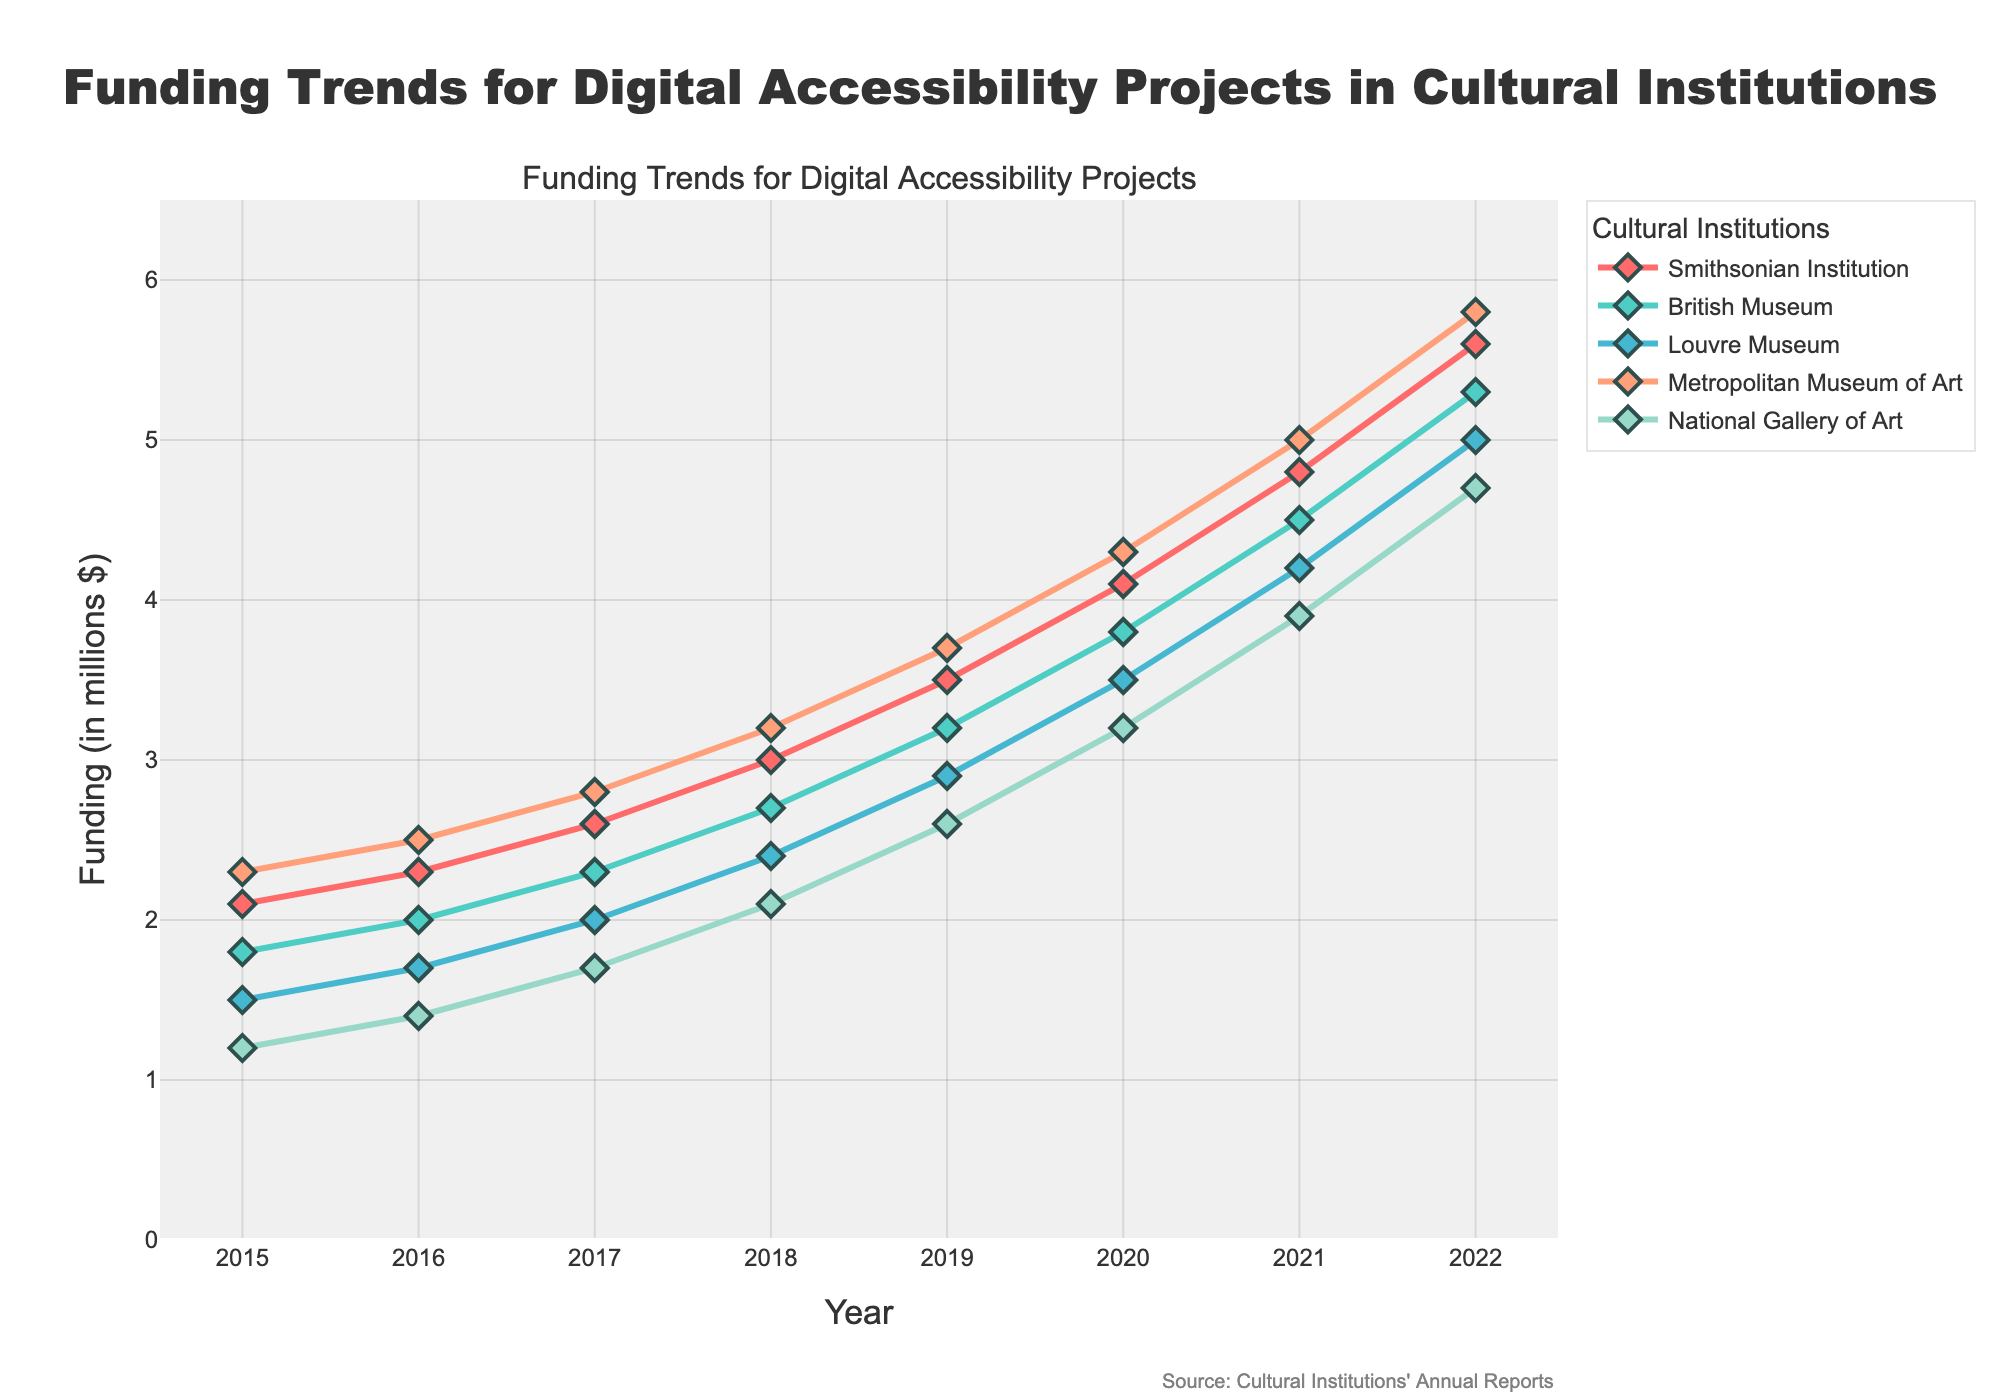What is the total funding for digital accessibility projects by the British Museum from 2015 to 2022? Sum the funding values for the British Museum from each year: 1.8 + 2.0 + 2.3 + 2.7 + 3.2 + 3.8 + 4.5 + 5.3
Answer: 25.6 Which museum had the highest funding for digital accessibility projects in 2022? Compare the funding values for all museums in 2022: Smithsonian Institution (5.6), British Museum (5.3), Louvre Museum (5.0), Metropolitan Museum of Art (5.8), National Gallery of Art (4.7). The Metropolitan Museum of Art had the highest funding.
Answer: Metropolitan Museum of Art Looking at the funding trend for the Louvre Museum, did it ever exceed $3 million before 2020? Check the values for the Louvre Museum from 2015 to 2019: 1.5, 1.7, 2.0, 2.4, 2.9. None of these values exceeded $3 million before 2020.
Answer: No In which year did the Smithsonian Institution see the largest year-over-year increase in funding? Calculate the year-over-year increase for the Smithsonian Institution: 
 2016-2015: 2.3 - 2.1 = 0.2
 2017-2016: 2.6 - 2.3 = 0.3
 2018-2017: 3.0 - 2.6 = 0.4
 2019-2018: 3.5 - 3.0 = 0.5 
 2020-2019: 4.1 - 3.5 = 0.6 
 2021-2020: 4.8 - 4.1 = 0.7 
 2022-2021: 5.6 - 4.8 = 0.8
 The largest increase was from 2021 to 2022.
Answer: 2021 to 2022 Which museum had the lowest funding for digital accessibility projects in 2019? Compare the funding values for all museums in 2019: Smithsonian Institution (3.5), British Museum (3.2), Louvre Museum (2.9), Metropolitan Museum of Art (3.7), National Gallery of Art (2.6). The National Gallery of Art had the lowest funding.
Answer: National Gallery of Art What was the average annual funding for the National Gallery of Art from 2015 to 2022? Sum the funding values for the National Gallery of Art from each year and divide by the number of years: (1.2 + 1.4 + 1.7 + 2.1 + 2.6 + 3.2 + 3.9 + 4.7) / 8 = 20.8 / 8
Answer: 2.6 Between which two consecutive years did the British Museum see the smallest increase in funding? Calculate the year-over-year increase for the British Museum:
2016-2015: 2.0 - 1.8 = 0.2
2017-2016: 2.3 - 2.0 = 0.3
2018-2017: 2.7 - 2.3 = 0.4
2019-2018: 3.2 - 2.7 = 0.5
2020-2019: 3.8 - 3.2 = 0.6
2021-2020: 4.5 - 3.8 = 0.7
2022-2021: 5.3 - 4.5 = 0.8
 The smallest increase was from 2015 to 2016.
Answer: 2015 to 2016 What is the combined funding for digital accessibility projects across all institutions in 2020? Sum the funding values for all museums in 2020: 4.1 (Smithsonian) + 3.8 (British) + 3.5 (Louvre) + 4.3 (Metropolitan) + 3.2 (National) = 18.9
Answer: 18.9 Which museum shows the most consistent year-over-year increase in funding from 2015 to 2022? Observe the trend for each museum:
  Smithsonian Institution: 2.1, 2.3, 2.6, 3.0, 3.5, 4.1, 4.8, 5.6 (consistent)
  British Museum: 1.8, 2.0, 2.3, 2.7, 3.2, 3.8, 4.5, 5.3 (consistent)
  Louvre Museum: 1.5, 1.7, 2.0, 2.4, 2.9, 3.5, 4.2, 5.0 (consistent)
  Metropolitan Museum of Art: 2.3, 2.5, 2.8, 3.2, 3.7, 4.3, 5.0, 5.8 (consistent)
  National Gallery of Art: 1.2, 1.4, 1.7, 2.1, 2.6, 3.2, 3.9, 4.7 (consistent)
 All show consistent increases, but Smithsonian Institution's increases are consistently spaced and largest on average.
Answer: Smithsonian Institution 